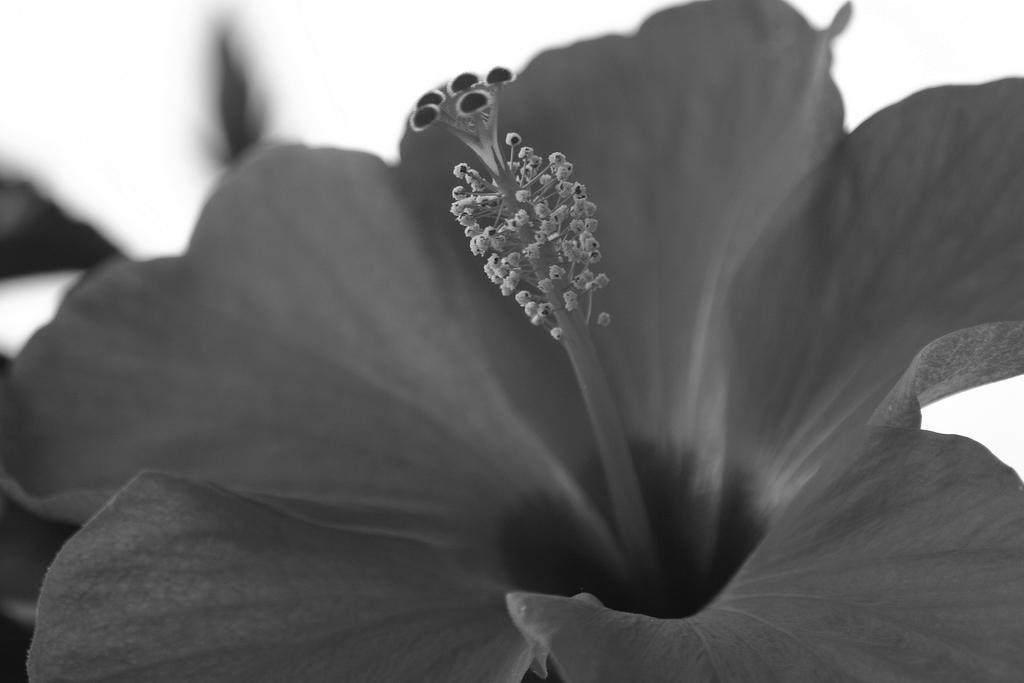What is the main subject of the image? There is a hibiscus in the center of the image. How many oranges are hanging from the hibiscus in the image? There are no oranges present in the image, as it features a hibiscus flower. What type of advice can be given by the hibiscus in the image? The hibiscus is a flower and cannot give advice, as it is not a sentient being. 